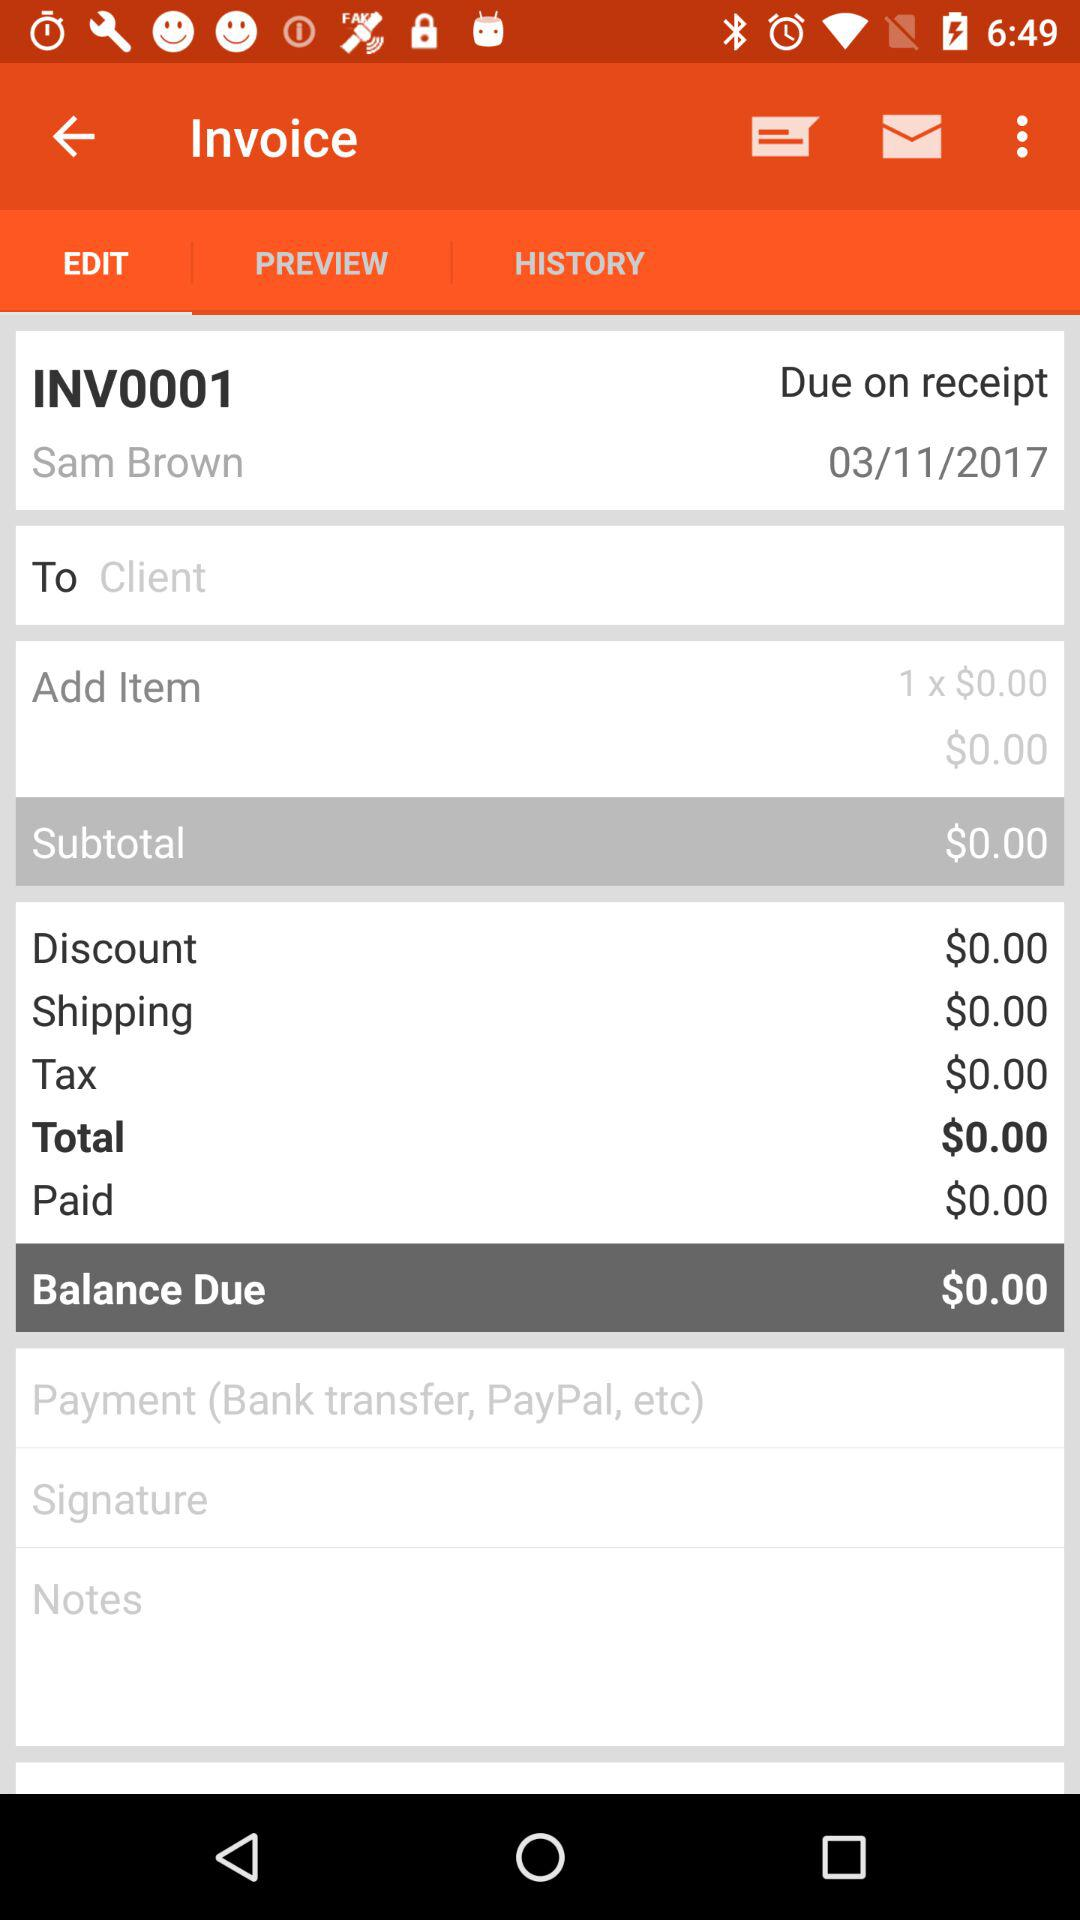What is the due date of the invoice?
Answer the question using a single word or phrase. 03/11/2017 